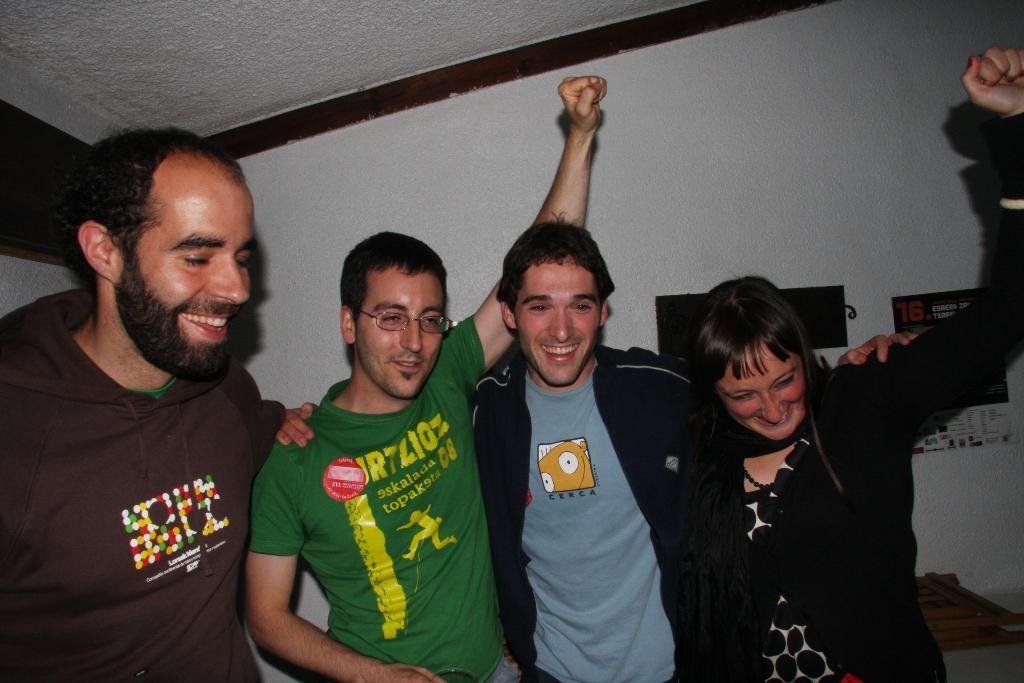Describe this image in one or two sentences. In this image there is a group of four persons who are standing in the middle. The man in the middle is raising his hand. On the right side there is a woman. In the background there is a wall to which there are labels. At the bottom there is a wooden chair on the floor. 